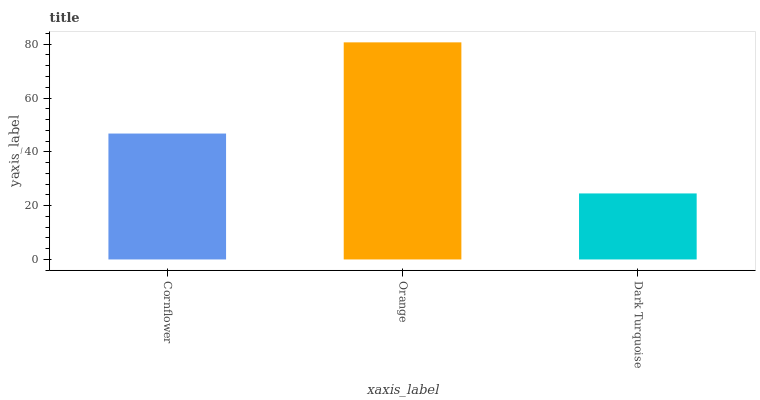Is Dark Turquoise the minimum?
Answer yes or no. Yes. Is Orange the maximum?
Answer yes or no. Yes. Is Orange the minimum?
Answer yes or no. No. Is Dark Turquoise the maximum?
Answer yes or no. No. Is Orange greater than Dark Turquoise?
Answer yes or no. Yes. Is Dark Turquoise less than Orange?
Answer yes or no. Yes. Is Dark Turquoise greater than Orange?
Answer yes or no. No. Is Orange less than Dark Turquoise?
Answer yes or no. No. Is Cornflower the high median?
Answer yes or no. Yes. Is Cornflower the low median?
Answer yes or no. Yes. Is Dark Turquoise the high median?
Answer yes or no. No. Is Orange the low median?
Answer yes or no. No. 